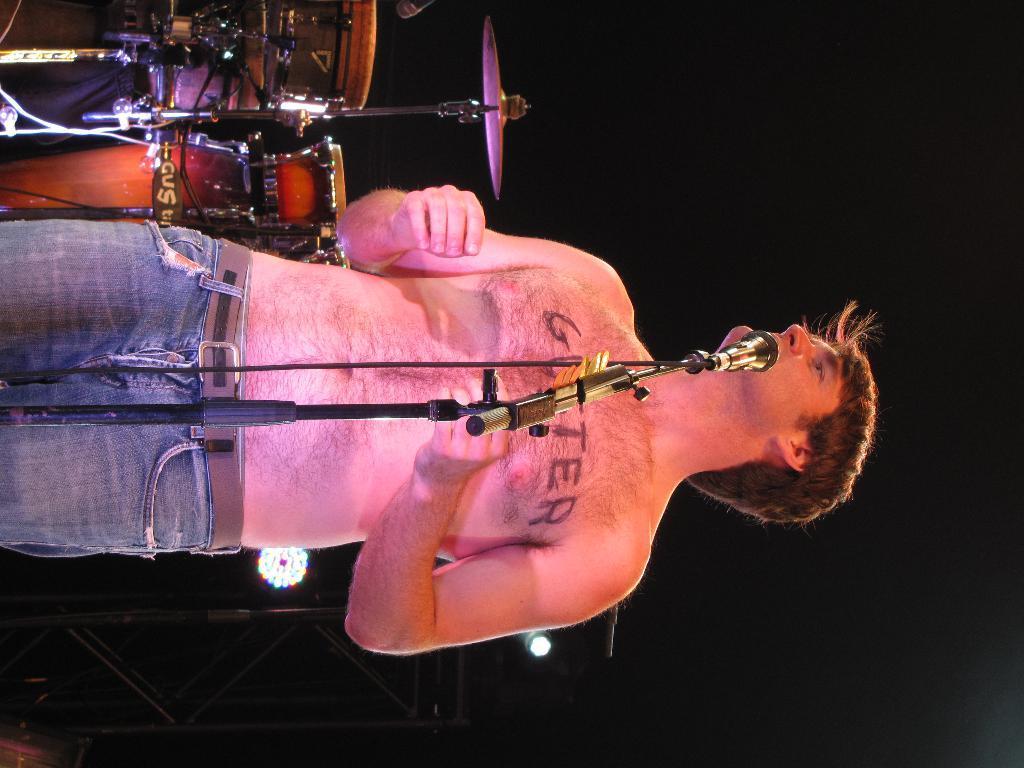Can you describe this image briefly? In this image there is one person standing and in front of him there is one mike, and on the left side of the image there are some drums. And at the bottom there are stands and lights, and there is black background. 